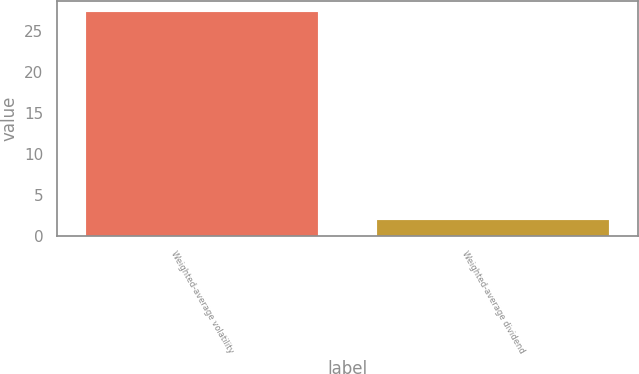Convert chart. <chart><loc_0><loc_0><loc_500><loc_500><bar_chart><fcel>Weighted-average volatility<fcel>Weighted-average dividend<nl><fcel>27.32<fcel>2<nl></chart> 